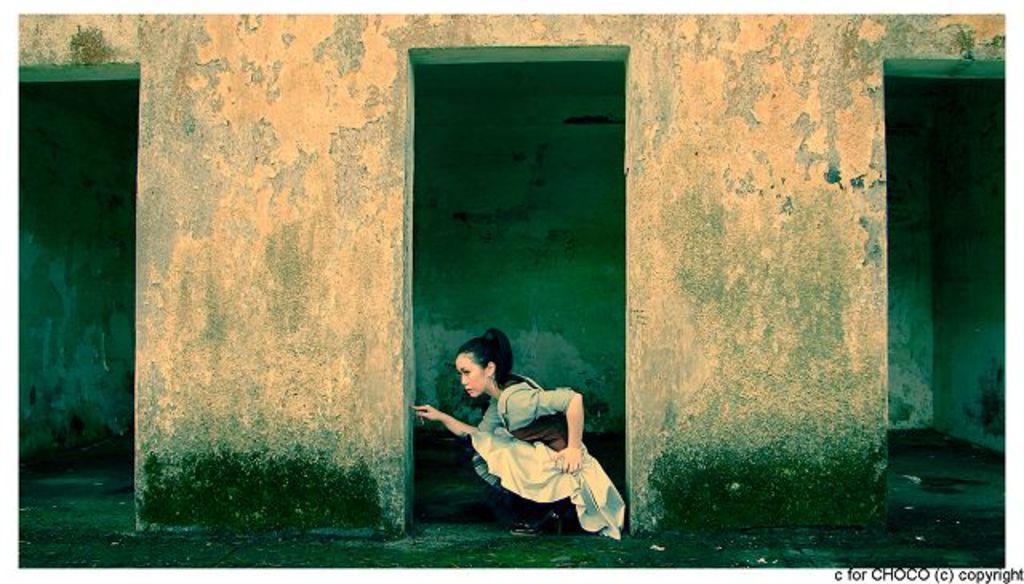Describe this image in one or two sentences. In this image there is a woman in between the pillars. Behind the woman there is a wall. 